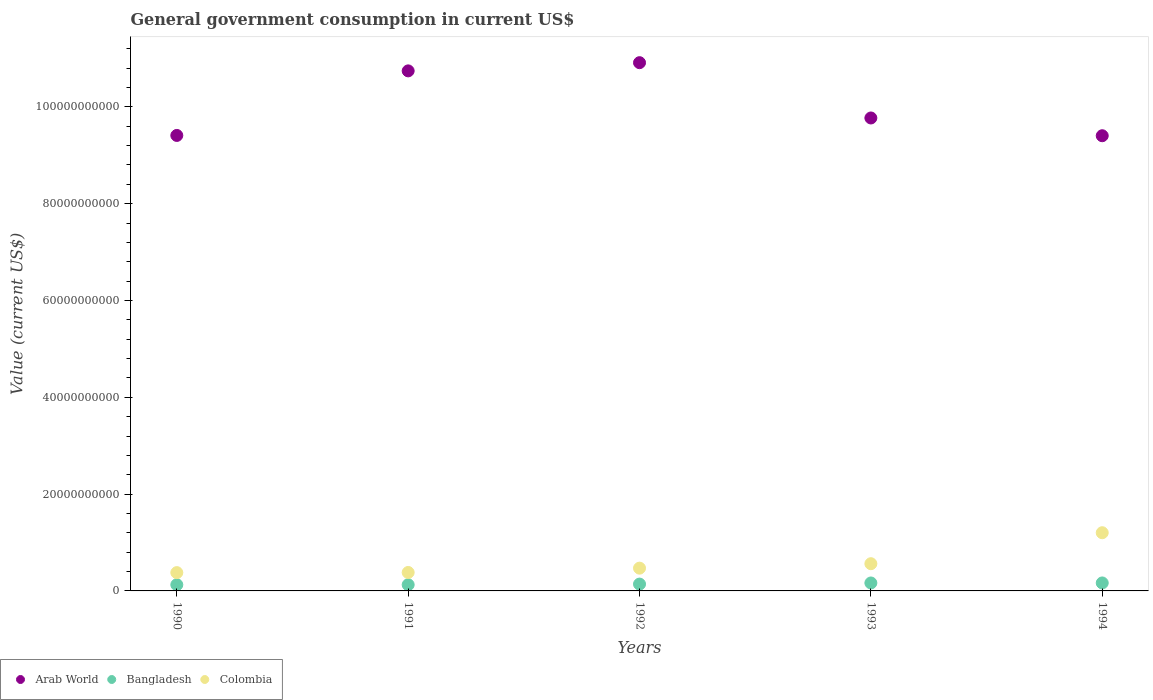How many different coloured dotlines are there?
Offer a terse response. 3. Is the number of dotlines equal to the number of legend labels?
Your answer should be very brief. Yes. What is the government conusmption in Arab World in 1990?
Your response must be concise. 9.41e+1. Across all years, what is the maximum government conusmption in Bangladesh?
Keep it short and to the point. 1.65e+09. Across all years, what is the minimum government conusmption in Arab World?
Your answer should be compact. 9.40e+1. What is the total government conusmption in Bangladesh in the graph?
Your answer should be very brief. 7.26e+09. What is the difference between the government conusmption in Colombia in 1991 and that in 1992?
Offer a terse response. -8.92e+08. What is the difference between the government conusmption in Arab World in 1991 and the government conusmption in Bangladesh in 1994?
Give a very brief answer. 1.06e+11. What is the average government conusmption in Arab World per year?
Offer a very short reply. 1.00e+11. In the year 1992, what is the difference between the government conusmption in Bangladesh and government conusmption in Arab World?
Provide a short and direct response. -1.08e+11. What is the ratio of the government conusmption in Colombia in 1991 to that in 1994?
Keep it short and to the point. 0.32. Is the government conusmption in Arab World in 1991 less than that in 1992?
Offer a terse response. Yes. What is the difference between the highest and the second highest government conusmption in Bangladesh?
Give a very brief answer. 5.96e+06. What is the difference between the highest and the lowest government conusmption in Colombia?
Your answer should be very brief. 8.24e+09. In how many years, is the government conusmption in Arab World greater than the average government conusmption in Arab World taken over all years?
Provide a short and direct response. 2. Is the sum of the government conusmption in Bangladesh in 1992 and 1994 greater than the maximum government conusmption in Arab World across all years?
Offer a very short reply. No. Is it the case that in every year, the sum of the government conusmption in Colombia and government conusmption in Bangladesh  is greater than the government conusmption in Arab World?
Provide a short and direct response. No. Does the government conusmption in Bangladesh monotonically increase over the years?
Offer a very short reply. No. Is the government conusmption in Colombia strictly greater than the government conusmption in Bangladesh over the years?
Make the answer very short. Yes. Is the government conusmption in Arab World strictly less than the government conusmption in Colombia over the years?
Offer a very short reply. No. How many dotlines are there?
Offer a very short reply. 3. Does the graph contain grids?
Make the answer very short. No. Where does the legend appear in the graph?
Ensure brevity in your answer.  Bottom left. How many legend labels are there?
Your answer should be very brief. 3. How are the legend labels stacked?
Your response must be concise. Horizontal. What is the title of the graph?
Provide a short and direct response. General government consumption in current US$. Does "Indonesia" appear as one of the legend labels in the graph?
Give a very brief answer. No. What is the label or title of the X-axis?
Keep it short and to the point. Years. What is the label or title of the Y-axis?
Your answer should be compact. Value (current US$). What is the Value (current US$) of Arab World in 1990?
Make the answer very short. 9.41e+1. What is the Value (current US$) of Bangladesh in 1990?
Give a very brief answer. 1.28e+09. What is the Value (current US$) of Colombia in 1990?
Make the answer very short. 3.78e+09. What is the Value (current US$) in Arab World in 1991?
Offer a terse response. 1.07e+11. What is the Value (current US$) in Bangladesh in 1991?
Your answer should be very brief. 1.28e+09. What is the Value (current US$) of Colombia in 1991?
Give a very brief answer. 3.81e+09. What is the Value (current US$) of Arab World in 1992?
Ensure brevity in your answer.  1.09e+11. What is the Value (current US$) of Bangladesh in 1992?
Ensure brevity in your answer.  1.41e+09. What is the Value (current US$) in Colombia in 1992?
Your answer should be very brief. 4.71e+09. What is the Value (current US$) in Arab World in 1993?
Offer a terse response. 9.77e+1. What is the Value (current US$) of Bangladesh in 1993?
Provide a succinct answer. 1.64e+09. What is the Value (current US$) in Colombia in 1993?
Ensure brevity in your answer.  5.62e+09. What is the Value (current US$) in Arab World in 1994?
Give a very brief answer. 9.40e+1. What is the Value (current US$) in Bangladesh in 1994?
Provide a succinct answer. 1.65e+09. What is the Value (current US$) of Colombia in 1994?
Make the answer very short. 1.20e+1. Across all years, what is the maximum Value (current US$) of Arab World?
Provide a succinct answer. 1.09e+11. Across all years, what is the maximum Value (current US$) of Bangladesh?
Provide a short and direct response. 1.65e+09. Across all years, what is the maximum Value (current US$) in Colombia?
Keep it short and to the point. 1.20e+1. Across all years, what is the minimum Value (current US$) in Arab World?
Make the answer very short. 9.40e+1. Across all years, what is the minimum Value (current US$) in Bangladesh?
Your answer should be very brief. 1.28e+09. Across all years, what is the minimum Value (current US$) in Colombia?
Your answer should be very brief. 3.78e+09. What is the total Value (current US$) in Arab World in the graph?
Ensure brevity in your answer.  5.02e+11. What is the total Value (current US$) of Bangladesh in the graph?
Offer a very short reply. 7.26e+09. What is the total Value (current US$) in Colombia in the graph?
Your answer should be very brief. 2.99e+1. What is the difference between the Value (current US$) of Arab World in 1990 and that in 1991?
Keep it short and to the point. -1.33e+1. What is the difference between the Value (current US$) in Bangladesh in 1990 and that in 1991?
Ensure brevity in your answer.  2.56e+05. What is the difference between the Value (current US$) in Colombia in 1990 and that in 1991?
Offer a terse response. -3.04e+07. What is the difference between the Value (current US$) in Arab World in 1990 and that in 1992?
Give a very brief answer. -1.50e+1. What is the difference between the Value (current US$) of Bangladesh in 1990 and that in 1992?
Offer a very short reply. -1.31e+08. What is the difference between the Value (current US$) in Colombia in 1990 and that in 1992?
Provide a short and direct response. -9.22e+08. What is the difference between the Value (current US$) in Arab World in 1990 and that in 1993?
Give a very brief answer. -3.61e+09. What is the difference between the Value (current US$) in Bangladesh in 1990 and that in 1993?
Offer a very short reply. -3.62e+08. What is the difference between the Value (current US$) of Colombia in 1990 and that in 1993?
Ensure brevity in your answer.  -1.84e+09. What is the difference between the Value (current US$) in Arab World in 1990 and that in 1994?
Offer a terse response. 6.06e+07. What is the difference between the Value (current US$) of Bangladesh in 1990 and that in 1994?
Ensure brevity in your answer.  -3.68e+08. What is the difference between the Value (current US$) in Colombia in 1990 and that in 1994?
Offer a very short reply. -8.24e+09. What is the difference between the Value (current US$) in Arab World in 1991 and that in 1992?
Your response must be concise. -1.69e+09. What is the difference between the Value (current US$) in Bangladesh in 1991 and that in 1992?
Ensure brevity in your answer.  -1.31e+08. What is the difference between the Value (current US$) in Colombia in 1991 and that in 1992?
Provide a short and direct response. -8.92e+08. What is the difference between the Value (current US$) of Arab World in 1991 and that in 1993?
Keep it short and to the point. 9.73e+09. What is the difference between the Value (current US$) of Bangladesh in 1991 and that in 1993?
Ensure brevity in your answer.  -3.63e+08. What is the difference between the Value (current US$) in Colombia in 1991 and that in 1993?
Keep it short and to the point. -1.81e+09. What is the difference between the Value (current US$) of Arab World in 1991 and that in 1994?
Provide a succinct answer. 1.34e+1. What is the difference between the Value (current US$) of Bangladesh in 1991 and that in 1994?
Your answer should be very brief. -3.68e+08. What is the difference between the Value (current US$) in Colombia in 1991 and that in 1994?
Offer a very short reply. -8.21e+09. What is the difference between the Value (current US$) of Arab World in 1992 and that in 1993?
Make the answer very short. 1.14e+1. What is the difference between the Value (current US$) in Bangladesh in 1992 and that in 1993?
Ensure brevity in your answer.  -2.32e+08. What is the difference between the Value (current US$) in Colombia in 1992 and that in 1993?
Provide a succinct answer. -9.19e+08. What is the difference between the Value (current US$) of Arab World in 1992 and that in 1994?
Your response must be concise. 1.51e+1. What is the difference between the Value (current US$) of Bangladesh in 1992 and that in 1994?
Ensure brevity in your answer.  -2.38e+08. What is the difference between the Value (current US$) in Colombia in 1992 and that in 1994?
Offer a very short reply. -7.32e+09. What is the difference between the Value (current US$) of Arab World in 1993 and that in 1994?
Your response must be concise. 3.67e+09. What is the difference between the Value (current US$) in Bangladesh in 1993 and that in 1994?
Make the answer very short. -5.96e+06. What is the difference between the Value (current US$) in Colombia in 1993 and that in 1994?
Offer a terse response. -6.40e+09. What is the difference between the Value (current US$) in Arab World in 1990 and the Value (current US$) in Bangladesh in 1991?
Give a very brief answer. 9.28e+1. What is the difference between the Value (current US$) in Arab World in 1990 and the Value (current US$) in Colombia in 1991?
Provide a short and direct response. 9.03e+1. What is the difference between the Value (current US$) of Bangladesh in 1990 and the Value (current US$) of Colombia in 1991?
Offer a terse response. -2.53e+09. What is the difference between the Value (current US$) of Arab World in 1990 and the Value (current US$) of Bangladesh in 1992?
Your answer should be compact. 9.27e+1. What is the difference between the Value (current US$) in Arab World in 1990 and the Value (current US$) in Colombia in 1992?
Your answer should be compact. 8.94e+1. What is the difference between the Value (current US$) in Bangladesh in 1990 and the Value (current US$) in Colombia in 1992?
Your answer should be compact. -3.42e+09. What is the difference between the Value (current US$) in Arab World in 1990 and the Value (current US$) in Bangladesh in 1993?
Keep it short and to the point. 9.25e+1. What is the difference between the Value (current US$) in Arab World in 1990 and the Value (current US$) in Colombia in 1993?
Give a very brief answer. 8.85e+1. What is the difference between the Value (current US$) of Bangladesh in 1990 and the Value (current US$) of Colombia in 1993?
Give a very brief answer. -4.34e+09. What is the difference between the Value (current US$) in Arab World in 1990 and the Value (current US$) in Bangladesh in 1994?
Give a very brief answer. 9.25e+1. What is the difference between the Value (current US$) of Arab World in 1990 and the Value (current US$) of Colombia in 1994?
Your answer should be compact. 8.21e+1. What is the difference between the Value (current US$) of Bangladesh in 1990 and the Value (current US$) of Colombia in 1994?
Make the answer very short. -1.07e+1. What is the difference between the Value (current US$) of Arab World in 1991 and the Value (current US$) of Bangladesh in 1992?
Your answer should be very brief. 1.06e+11. What is the difference between the Value (current US$) in Arab World in 1991 and the Value (current US$) in Colombia in 1992?
Provide a succinct answer. 1.03e+11. What is the difference between the Value (current US$) of Bangladesh in 1991 and the Value (current US$) of Colombia in 1992?
Your response must be concise. -3.42e+09. What is the difference between the Value (current US$) of Arab World in 1991 and the Value (current US$) of Bangladesh in 1993?
Offer a very short reply. 1.06e+11. What is the difference between the Value (current US$) of Arab World in 1991 and the Value (current US$) of Colombia in 1993?
Provide a succinct answer. 1.02e+11. What is the difference between the Value (current US$) of Bangladesh in 1991 and the Value (current US$) of Colombia in 1993?
Keep it short and to the point. -4.34e+09. What is the difference between the Value (current US$) of Arab World in 1991 and the Value (current US$) of Bangladesh in 1994?
Your answer should be very brief. 1.06e+11. What is the difference between the Value (current US$) in Arab World in 1991 and the Value (current US$) in Colombia in 1994?
Your response must be concise. 9.54e+1. What is the difference between the Value (current US$) in Bangladesh in 1991 and the Value (current US$) in Colombia in 1994?
Provide a short and direct response. -1.07e+1. What is the difference between the Value (current US$) of Arab World in 1992 and the Value (current US$) of Bangladesh in 1993?
Ensure brevity in your answer.  1.07e+11. What is the difference between the Value (current US$) of Arab World in 1992 and the Value (current US$) of Colombia in 1993?
Make the answer very short. 1.04e+11. What is the difference between the Value (current US$) of Bangladesh in 1992 and the Value (current US$) of Colombia in 1993?
Provide a short and direct response. -4.21e+09. What is the difference between the Value (current US$) of Arab World in 1992 and the Value (current US$) of Bangladesh in 1994?
Give a very brief answer. 1.07e+11. What is the difference between the Value (current US$) in Arab World in 1992 and the Value (current US$) in Colombia in 1994?
Your answer should be compact. 9.71e+1. What is the difference between the Value (current US$) of Bangladesh in 1992 and the Value (current US$) of Colombia in 1994?
Ensure brevity in your answer.  -1.06e+1. What is the difference between the Value (current US$) of Arab World in 1993 and the Value (current US$) of Bangladesh in 1994?
Offer a terse response. 9.61e+1. What is the difference between the Value (current US$) in Arab World in 1993 and the Value (current US$) in Colombia in 1994?
Provide a short and direct response. 8.57e+1. What is the difference between the Value (current US$) in Bangladesh in 1993 and the Value (current US$) in Colombia in 1994?
Make the answer very short. -1.04e+1. What is the average Value (current US$) in Arab World per year?
Your answer should be compact. 1.00e+11. What is the average Value (current US$) in Bangladesh per year?
Your response must be concise. 1.45e+09. What is the average Value (current US$) of Colombia per year?
Provide a short and direct response. 5.99e+09. In the year 1990, what is the difference between the Value (current US$) in Arab World and Value (current US$) in Bangladesh?
Your response must be concise. 9.28e+1. In the year 1990, what is the difference between the Value (current US$) of Arab World and Value (current US$) of Colombia?
Provide a short and direct response. 9.03e+1. In the year 1990, what is the difference between the Value (current US$) of Bangladesh and Value (current US$) of Colombia?
Offer a terse response. -2.50e+09. In the year 1991, what is the difference between the Value (current US$) of Arab World and Value (current US$) of Bangladesh?
Give a very brief answer. 1.06e+11. In the year 1991, what is the difference between the Value (current US$) of Arab World and Value (current US$) of Colombia?
Provide a short and direct response. 1.04e+11. In the year 1991, what is the difference between the Value (current US$) of Bangladesh and Value (current US$) of Colombia?
Provide a short and direct response. -2.53e+09. In the year 1992, what is the difference between the Value (current US$) in Arab World and Value (current US$) in Bangladesh?
Make the answer very short. 1.08e+11. In the year 1992, what is the difference between the Value (current US$) in Arab World and Value (current US$) in Colombia?
Your answer should be compact. 1.04e+11. In the year 1992, what is the difference between the Value (current US$) in Bangladesh and Value (current US$) in Colombia?
Your answer should be compact. -3.29e+09. In the year 1993, what is the difference between the Value (current US$) in Arab World and Value (current US$) in Bangladesh?
Ensure brevity in your answer.  9.61e+1. In the year 1993, what is the difference between the Value (current US$) of Arab World and Value (current US$) of Colombia?
Offer a very short reply. 9.21e+1. In the year 1993, what is the difference between the Value (current US$) in Bangladesh and Value (current US$) in Colombia?
Keep it short and to the point. -3.98e+09. In the year 1994, what is the difference between the Value (current US$) of Arab World and Value (current US$) of Bangladesh?
Offer a terse response. 9.24e+1. In the year 1994, what is the difference between the Value (current US$) of Arab World and Value (current US$) of Colombia?
Offer a terse response. 8.20e+1. In the year 1994, what is the difference between the Value (current US$) in Bangladesh and Value (current US$) in Colombia?
Keep it short and to the point. -1.04e+1. What is the ratio of the Value (current US$) in Arab World in 1990 to that in 1991?
Offer a terse response. 0.88. What is the ratio of the Value (current US$) of Bangladesh in 1990 to that in 1991?
Your answer should be very brief. 1. What is the ratio of the Value (current US$) in Colombia in 1990 to that in 1991?
Offer a terse response. 0.99. What is the ratio of the Value (current US$) of Arab World in 1990 to that in 1992?
Offer a very short reply. 0.86. What is the ratio of the Value (current US$) of Bangladesh in 1990 to that in 1992?
Provide a short and direct response. 0.91. What is the ratio of the Value (current US$) of Colombia in 1990 to that in 1992?
Your answer should be very brief. 0.8. What is the ratio of the Value (current US$) of Arab World in 1990 to that in 1993?
Your response must be concise. 0.96. What is the ratio of the Value (current US$) of Bangladesh in 1990 to that in 1993?
Provide a succinct answer. 0.78. What is the ratio of the Value (current US$) in Colombia in 1990 to that in 1993?
Give a very brief answer. 0.67. What is the ratio of the Value (current US$) of Bangladesh in 1990 to that in 1994?
Ensure brevity in your answer.  0.78. What is the ratio of the Value (current US$) of Colombia in 1990 to that in 1994?
Give a very brief answer. 0.31. What is the ratio of the Value (current US$) of Arab World in 1991 to that in 1992?
Offer a very short reply. 0.98. What is the ratio of the Value (current US$) of Bangladesh in 1991 to that in 1992?
Offer a terse response. 0.91. What is the ratio of the Value (current US$) of Colombia in 1991 to that in 1992?
Keep it short and to the point. 0.81. What is the ratio of the Value (current US$) in Arab World in 1991 to that in 1993?
Make the answer very short. 1.1. What is the ratio of the Value (current US$) in Bangladesh in 1991 to that in 1993?
Offer a very short reply. 0.78. What is the ratio of the Value (current US$) in Colombia in 1991 to that in 1993?
Make the answer very short. 0.68. What is the ratio of the Value (current US$) of Arab World in 1991 to that in 1994?
Your answer should be very brief. 1.14. What is the ratio of the Value (current US$) of Bangladesh in 1991 to that in 1994?
Offer a terse response. 0.78. What is the ratio of the Value (current US$) of Colombia in 1991 to that in 1994?
Your answer should be very brief. 0.32. What is the ratio of the Value (current US$) in Arab World in 1992 to that in 1993?
Your answer should be compact. 1.12. What is the ratio of the Value (current US$) of Bangladesh in 1992 to that in 1993?
Keep it short and to the point. 0.86. What is the ratio of the Value (current US$) of Colombia in 1992 to that in 1993?
Offer a terse response. 0.84. What is the ratio of the Value (current US$) in Arab World in 1992 to that in 1994?
Your response must be concise. 1.16. What is the ratio of the Value (current US$) in Bangladesh in 1992 to that in 1994?
Make the answer very short. 0.86. What is the ratio of the Value (current US$) of Colombia in 1992 to that in 1994?
Ensure brevity in your answer.  0.39. What is the ratio of the Value (current US$) of Arab World in 1993 to that in 1994?
Make the answer very short. 1.04. What is the ratio of the Value (current US$) in Colombia in 1993 to that in 1994?
Your answer should be compact. 0.47. What is the difference between the highest and the second highest Value (current US$) in Arab World?
Your response must be concise. 1.69e+09. What is the difference between the highest and the second highest Value (current US$) of Bangladesh?
Ensure brevity in your answer.  5.96e+06. What is the difference between the highest and the second highest Value (current US$) of Colombia?
Your response must be concise. 6.40e+09. What is the difference between the highest and the lowest Value (current US$) of Arab World?
Offer a very short reply. 1.51e+1. What is the difference between the highest and the lowest Value (current US$) of Bangladesh?
Ensure brevity in your answer.  3.68e+08. What is the difference between the highest and the lowest Value (current US$) in Colombia?
Your answer should be compact. 8.24e+09. 